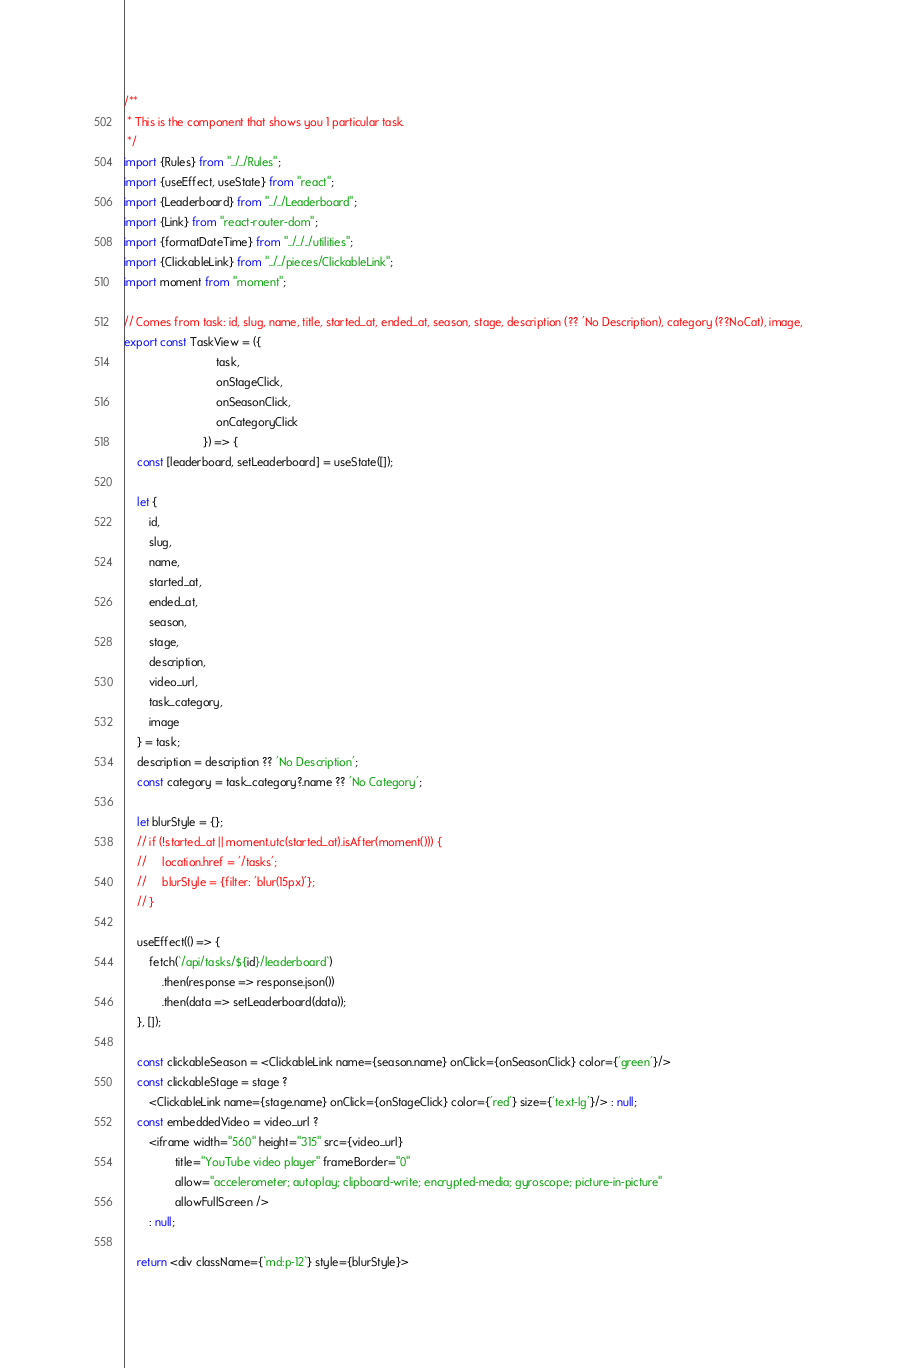<code> <loc_0><loc_0><loc_500><loc_500><_JavaScript_>/**
 * This is the component that shows you 1 particular task.
 */
import {Rules} from "../../Rules";
import {useEffect, useState} from "react";
import {Leaderboard} from "../../Leaderboard";
import {Link} from "react-router-dom";
import {formatDateTime} from "../../../utilities";
import {ClickableLink} from "../../pieces/ClickableLink";
import moment from "moment";

// Comes from task: id, slug, name, title, started_at, ended_at, season, stage, description (?? 'No Description), category (??NoCat), image,
export const TaskView = ({
                             task,
                             onStageClick,
                             onSeasonClick,
                             onCategoryClick
                         }) => {
    const [leaderboard, setLeaderboard] = useState([]);

    let {
        id,
        slug,
        name,
        started_at,
        ended_at,
        season,
        stage,
        description,
        video_url,
        task_category,
        image
    } = task;
    description = description ?? 'No Description';
    const category = task_category?.name ?? 'No Category';

    let blurStyle = {};
    // if (!started_at || moment.utc(started_at).isAfter(moment())) {
    //     location.href = '/tasks';
    //     blurStyle = {filter: 'blur(15px)'};
    // }

    useEffect(() => {
        fetch(`/api/tasks/${id}/leaderboard`)
            .then(response => response.json())
            .then(data => setLeaderboard(data));
    }, []);

    const clickableSeason = <ClickableLink name={season.name} onClick={onSeasonClick} color={'green'}/>
    const clickableStage = stage ?
        <ClickableLink name={stage.name} onClick={onStageClick} color={'red'} size={'text-lg'}/> : null;
    const embeddedVideo = video_url ?
        <iframe width="560" height="315" src={video_url}
                title="YouTube video player" frameBorder="0"
                allow="accelerometer; autoplay; clipboard-write; encrypted-media; gyroscope; picture-in-picture"
                allowFullScreen />
        : null;

    return <div className={`md:p-12`} style={blurStyle}></code> 